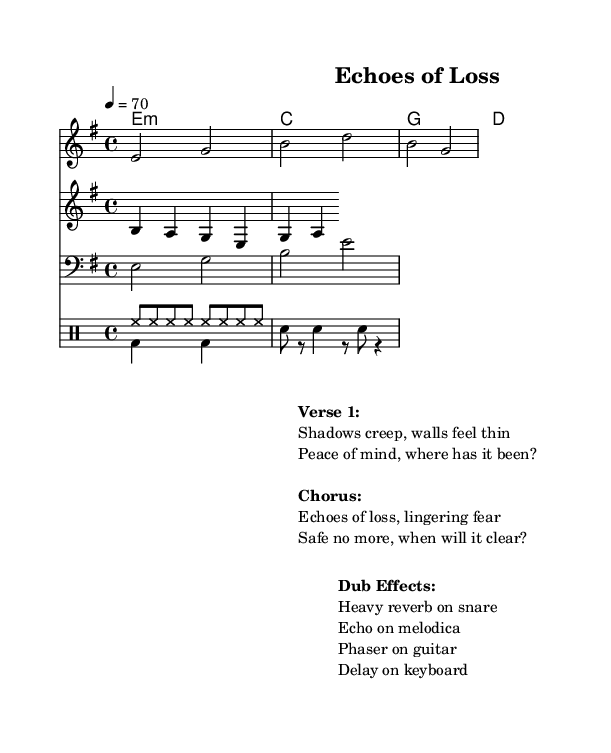What is the key signature of this music? The key signature indicating one sharp (F#) shows that the piece is in E minor.
Answer: E minor What is the time signature in this piece? The time signature is 4/4, meaning there are four beats in each measure.
Answer: 4/4 What is the tempo marking of the piece? The tempo marking shows that the music is set to play at a speed of 70 beats per minute.
Answer: 70 What type of rhythm is indicated in the drum pattern up? The drum pattern up consists of eight hi-hat notes in a row, showing a steady rhythmic pulse.
Answer: Steady pulse What effects are applied to the melodica in the Dub section? The sheet music indicates that an echo effect is used on the melodica to enhance the sound.
Answer: Echo What is the emotional theme presented in the chorus? The theme of the chorus revolves around feelings of loss and fear, reflecting psychological impacts of theft.
Answer: Loss and fear What is the main focus of the lyrics in Verse 1? The lyrics of Verse 1 focus on feelings of vulnerability and anxiety regarding safety and security.
Answer: Vulnerability and anxiety 